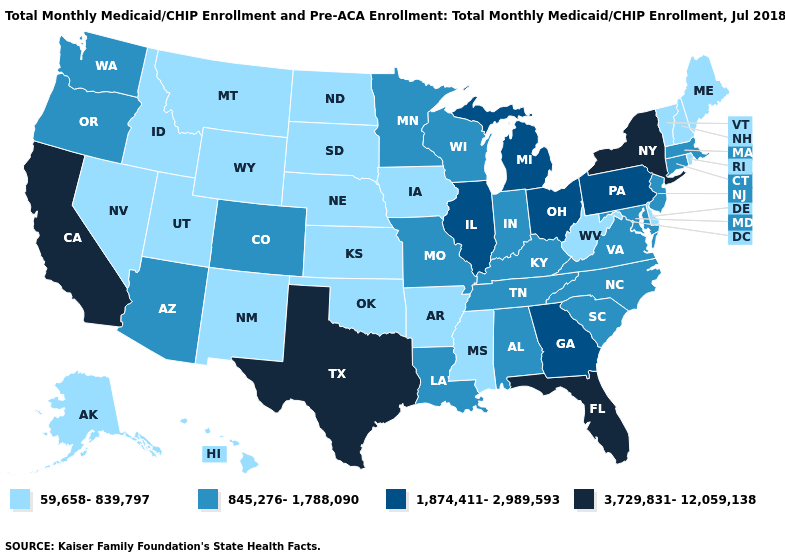Name the states that have a value in the range 845,276-1,788,090?
Give a very brief answer. Alabama, Arizona, Colorado, Connecticut, Indiana, Kentucky, Louisiana, Maryland, Massachusetts, Minnesota, Missouri, New Jersey, North Carolina, Oregon, South Carolina, Tennessee, Virginia, Washington, Wisconsin. What is the lowest value in the USA?
Answer briefly. 59,658-839,797. Among the states that border New Mexico , does Utah have the lowest value?
Short answer required. Yes. Among the states that border South Dakota , does Nebraska have the highest value?
Answer briefly. No. What is the value of Oklahoma?
Concise answer only. 59,658-839,797. Does the first symbol in the legend represent the smallest category?
Concise answer only. Yes. What is the highest value in states that border Rhode Island?
Keep it brief. 845,276-1,788,090. Name the states that have a value in the range 59,658-839,797?
Answer briefly. Alaska, Arkansas, Delaware, Hawaii, Idaho, Iowa, Kansas, Maine, Mississippi, Montana, Nebraska, Nevada, New Hampshire, New Mexico, North Dakota, Oklahoma, Rhode Island, South Dakota, Utah, Vermont, West Virginia, Wyoming. What is the value of New Jersey?
Give a very brief answer. 845,276-1,788,090. Name the states that have a value in the range 59,658-839,797?
Answer briefly. Alaska, Arkansas, Delaware, Hawaii, Idaho, Iowa, Kansas, Maine, Mississippi, Montana, Nebraska, Nevada, New Hampshire, New Mexico, North Dakota, Oklahoma, Rhode Island, South Dakota, Utah, Vermont, West Virginia, Wyoming. Does Vermont have the same value as Ohio?
Give a very brief answer. No. Which states hav the highest value in the West?
Give a very brief answer. California. Name the states that have a value in the range 1,874,411-2,989,593?
Quick response, please. Georgia, Illinois, Michigan, Ohio, Pennsylvania. Does Alaska have the same value as Montana?
Concise answer only. Yes. What is the value of Mississippi?
Quick response, please. 59,658-839,797. 